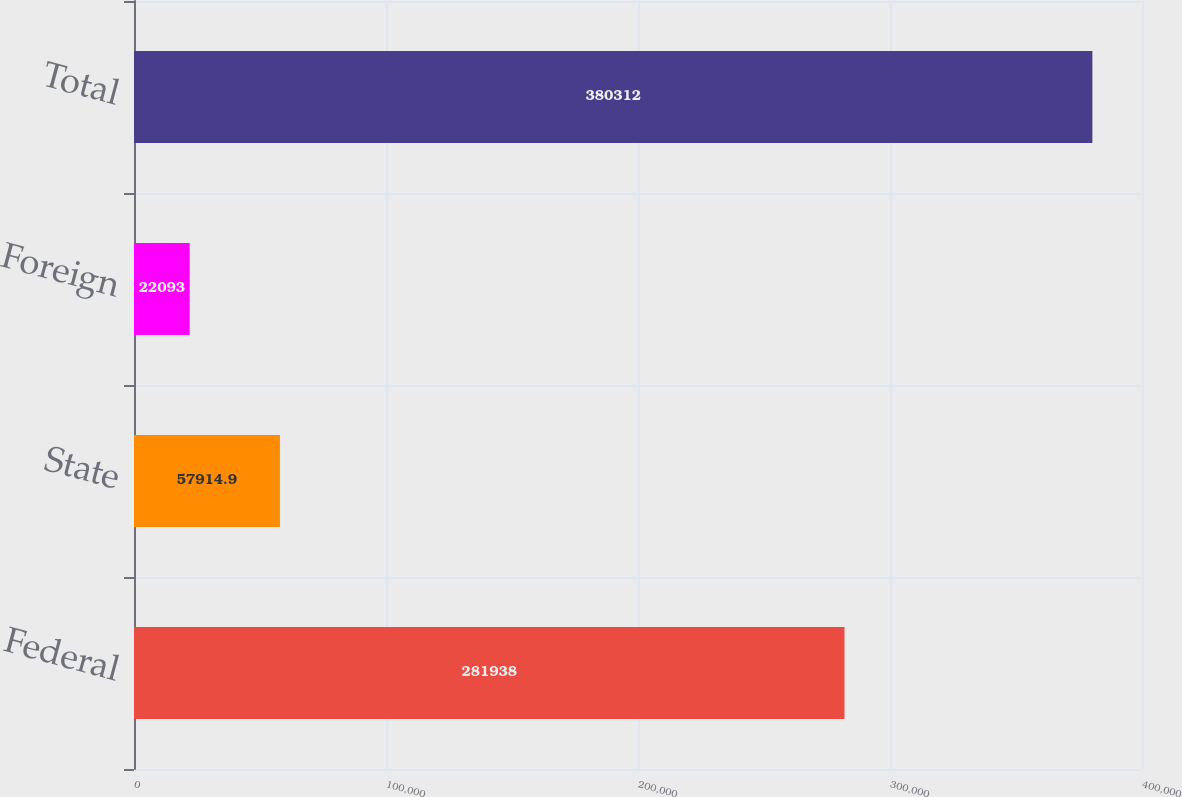<chart> <loc_0><loc_0><loc_500><loc_500><bar_chart><fcel>Federal<fcel>State<fcel>Foreign<fcel>Total<nl><fcel>281938<fcel>57914.9<fcel>22093<fcel>380312<nl></chart> 